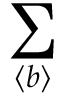Convert formula to latex. <formula><loc_0><loc_0><loc_500><loc_500>\sum _ { \langle b \rangle }</formula> 